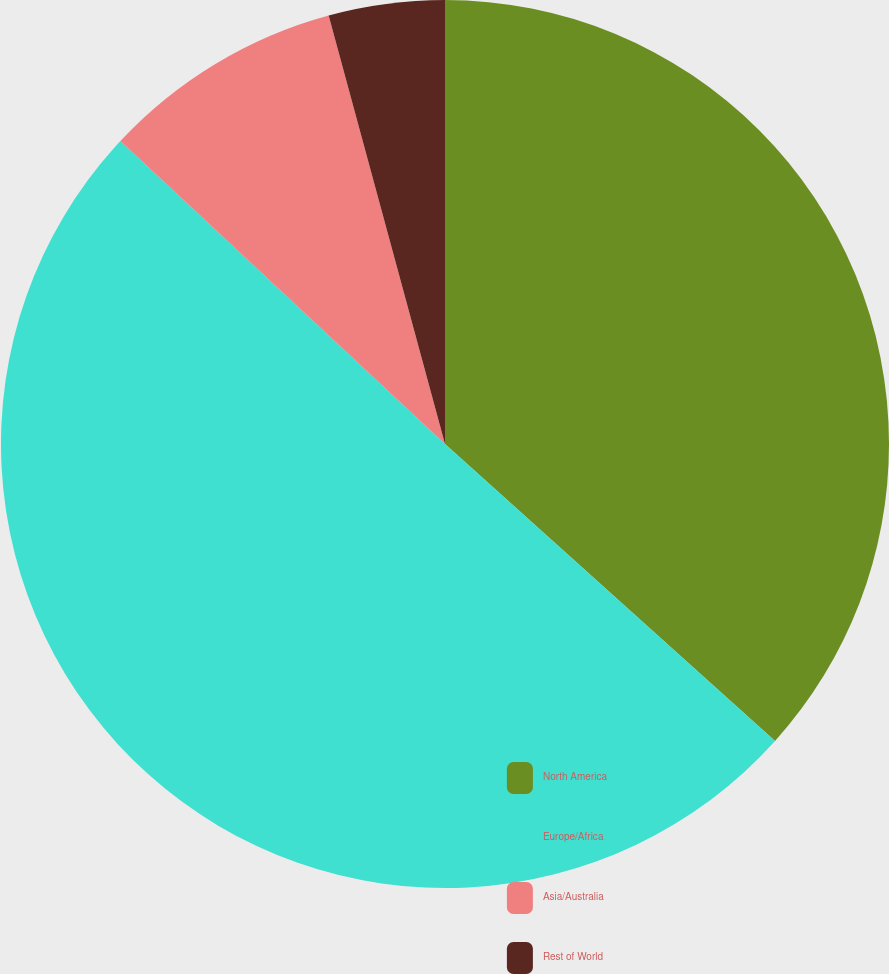Convert chart. <chart><loc_0><loc_0><loc_500><loc_500><pie_chart><fcel>North America<fcel>Europe/Africa<fcel>Asia/Australia<fcel>Rest of World<nl><fcel>36.66%<fcel>50.29%<fcel>8.83%<fcel>4.22%<nl></chart> 